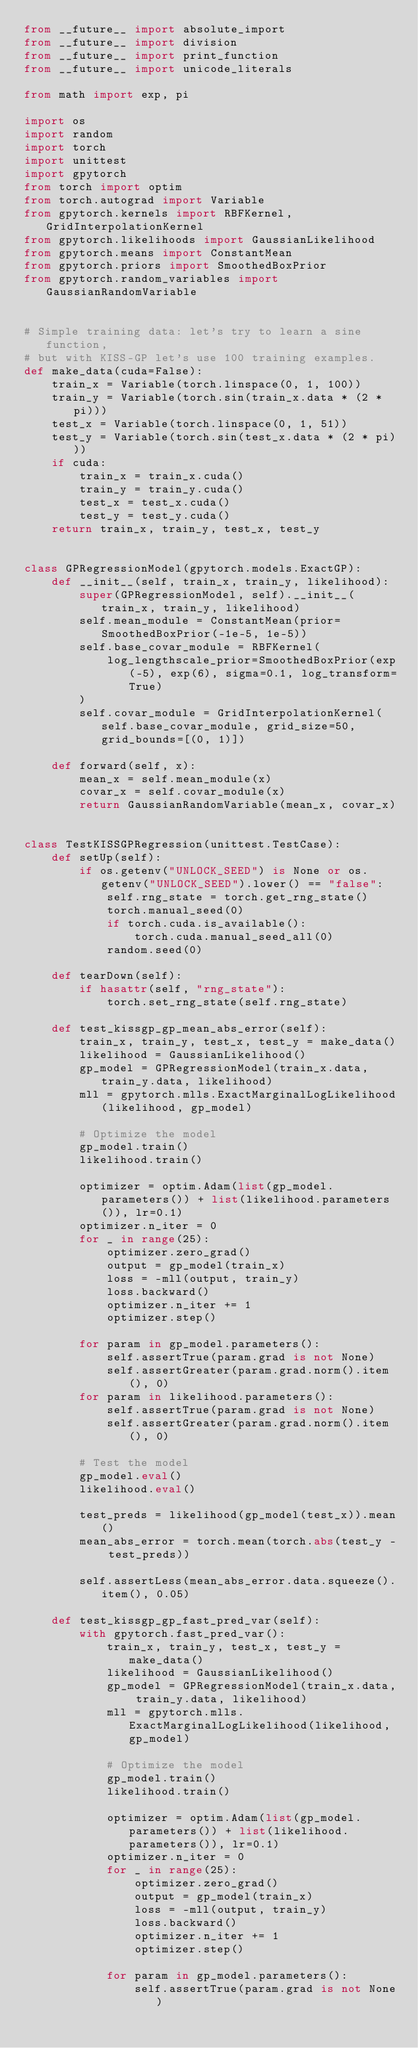Convert code to text. <code><loc_0><loc_0><loc_500><loc_500><_Python_>from __future__ import absolute_import
from __future__ import division
from __future__ import print_function
from __future__ import unicode_literals

from math import exp, pi

import os
import random
import torch
import unittest
import gpytorch
from torch import optim
from torch.autograd import Variable
from gpytorch.kernels import RBFKernel, GridInterpolationKernel
from gpytorch.likelihoods import GaussianLikelihood
from gpytorch.means import ConstantMean
from gpytorch.priors import SmoothedBoxPrior
from gpytorch.random_variables import GaussianRandomVariable


# Simple training data: let's try to learn a sine function,
# but with KISS-GP let's use 100 training examples.
def make_data(cuda=False):
    train_x = Variable(torch.linspace(0, 1, 100))
    train_y = Variable(torch.sin(train_x.data * (2 * pi)))
    test_x = Variable(torch.linspace(0, 1, 51))
    test_y = Variable(torch.sin(test_x.data * (2 * pi)))
    if cuda:
        train_x = train_x.cuda()
        train_y = train_y.cuda()
        test_x = test_x.cuda()
        test_y = test_y.cuda()
    return train_x, train_y, test_x, test_y


class GPRegressionModel(gpytorch.models.ExactGP):
    def __init__(self, train_x, train_y, likelihood):
        super(GPRegressionModel, self).__init__(train_x, train_y, likelihood)
        self.mean_module = ConstantMean(prior=SmoothedBoxPrior(-1e-5, 1e-5))
        self.base_covar_module = RBFKernel(
            log_lengthscale_prior=SmoothedBoxPrior(exp(-5), exp(6), sigma=0.1, log_transform=True)
        )
        self.covar_module = GridInterpolationKernel(self.base_covar_module, grid_size=50, grid_bounds=[(0, 1)])

    def forward(self, x):
        mean_x = self.mean_module(x)
        covar_x = self.covar_module(x)
        return GaussianRandomVariable(mean_x, covar_x)


class TestKISSGPRegression(unittest.TestCase):
    def setUp(self):
        if os.getenv("UNLOCK_SEED") is None or os.getenv("UNLOCK_SEED").lower() == "false":
            self.rng_state = torch.get_rng_state()
            torch.manual_seed(0)
            if torch.cuda.is_available():
                torch.cuda.manual_seed_all(0)
            random.seed(0)

    def tearDown(self):
        if hasattr(self, "rng_state"):
            torch.set_rng_state(self.rng_state)

    def test_kissgp_gp_mean_abs_error(self):
        train_x, train_y, test_x, test_y = make_data()
        likelihood = GaussianLikelihood()
        gp_model = GPRegressionModel(train_x.data, train_y.data, likelihood)
        mll = gpytorch.mlls.ExactMarginalLogLikelihood(likelihood, gp_model)

        # Optimize the model
        gp_model.train()
        likelihood.train()

        optimizer = optim.Adam(list(gp_model.parameters()) + list(likelihood.parameters()), lr=0.1)
        optimizer.n_iter = 0
        for _ in range(25):
            optimizer.zero_grad()
            output = gp_model(train_x)
            loss = -mll(output, train_y)
            loss.backward()
            optimizer.n_iter += 1
            optimizer.step()

        for param in gp_model.parameters():
            self.assertTrue(param.grad is not None)
            self.assertGreater(param.grad.norm().item(), 0)
        for param in likelihood.parameters():
            self.assertTrue(param.grad is not None)
            self.assertGreater(param.grad.norm().item(), 0)

        # Test the model
        gp_model.eval()
        likelihood.eval()

        test_preds = likelihood(gp_model(test_x)).mean()
        mean_abs_error = torch.mean(torch.abs(test_y - test_preds))

        self.assertLess(mean_abs_error.data.squeeze().item(), 0.05)

    def test_kissgp_gp_fast_pred_var(self):
        with gpytorch.fast_pred_var():
            train_x, train_y, test_x, test_y = make_data()
            likelihood = GaussianLikelihood()
            gp_model = GPRegressionModel(train_x.data, train_y.data, likelihood)
            mll = gpytorch.mlls.ExactMarginalLogLikelihood(likelihood, gp_model)

            # Optimize the model
            gp_model.train()
            likelihood.train()

            optimizer = optim.Adam(list(gp_model.parameters()) + list(likelihood.parameters()), lr=0.1)
            optimizer.n_iter = 0
            for _ in range(25):
                optimizer.zero_grad()
                output = gp_model(train_x)
                loss = -mll(output, train_y)
                loss.backward()
                optimizer.n_iter += 1
                optimizer.step()

            for param in gp_model.parameters():
                self.assertTrue(param.grad is not None)</code> 